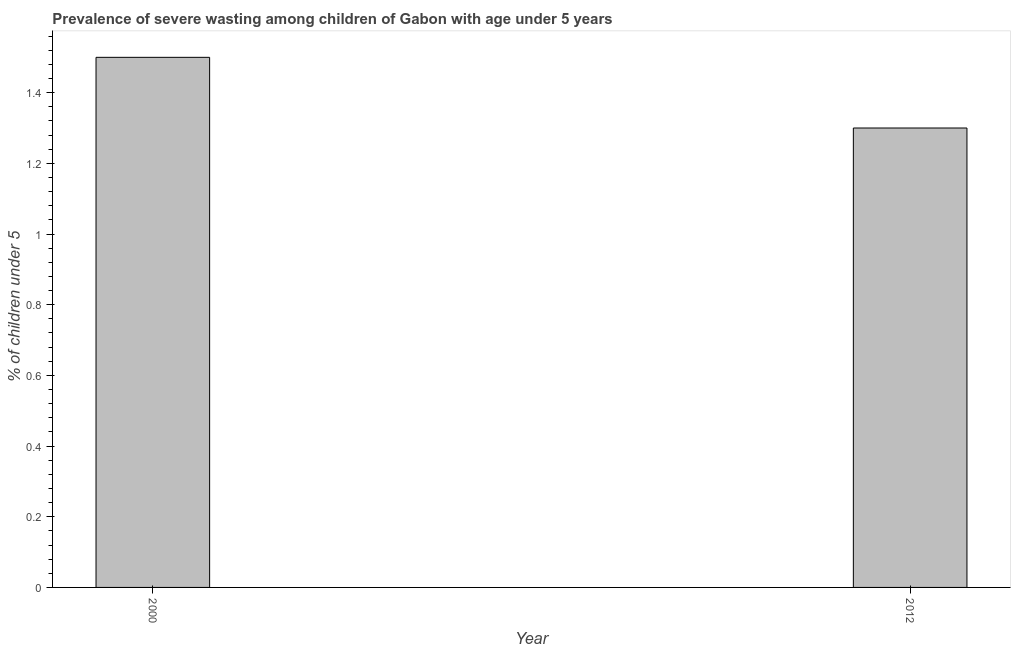What is the title of the graph?
Offer a very short reply. Prevalence of severe wasting among children of Gabon with age under 5 years. What is the label or title of the X-axis?
Your answer should be very brief. Year. What is the label or title of the Y-axis?
Your answer should be compact.  % of children under 5. What is the prevalence of severe wasting in 2000?
Give a very brief answer. 1.5. Across all years, what is the maximum prevalence of severe wasting?
Your response must be concise. 1.5. Across all years, what is the minimum prevalence of severe wasting?
Ensure brevity in your answer.  1.3. In which year was the prevalence of severe wasting minimum?
Offer a terse response. 2012. What is the sum of the prevalence of severe wasting?
Offer a terse response. 2.8. What is the difference between the prevalence of severe wasting in 2000 and 2012?
Offer a terse response. 0.2. What is the median prevalence of severe wasting?
Your answer should be compact. 1.4. In how many years, is the prevalence of severe wasting greater than 0.32 %?
Your response must be concise. 2. What is the ratio of the prevalence of severe wasting in 2000 to that in 2012?
Keep it short and to the point. 1.15. Is the prevalence of severe wasting in 2000 less than that in 2012?
Provide a short and direct response. No. Are the values on the major ticks of Y-axis written in scientific E-notation?
Your response must be concise. No. What is the  % of children under 5 of 2000?
Ensure brevity in your answer.  1.5. What is the  % of children under 5 of 2012?
Keep it short and to the point. 1.3. What is the ratio of the  % of children under 5 in 2000 to that in 2012?
Make the answer very short. 1.15. 